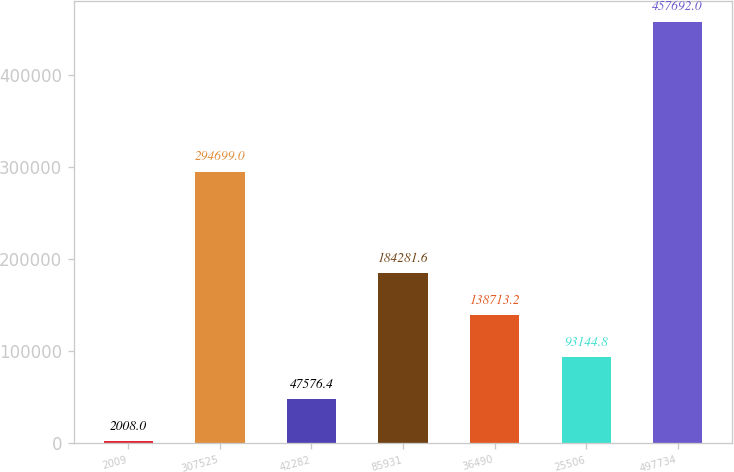<chart> <loc_0><loc_0><loc_500><loc_500><bar_chart><fcel>2009<fcel>307525<fcel>42282<fcel>85931<fcel>36490<fcel>25506<fcel>497734<nl><fcel>2008<fcel>294699<fcel>47576.4<fcel>184282<fcel>138713<fcel>93144.8<fcel>457692<nl></chart> 